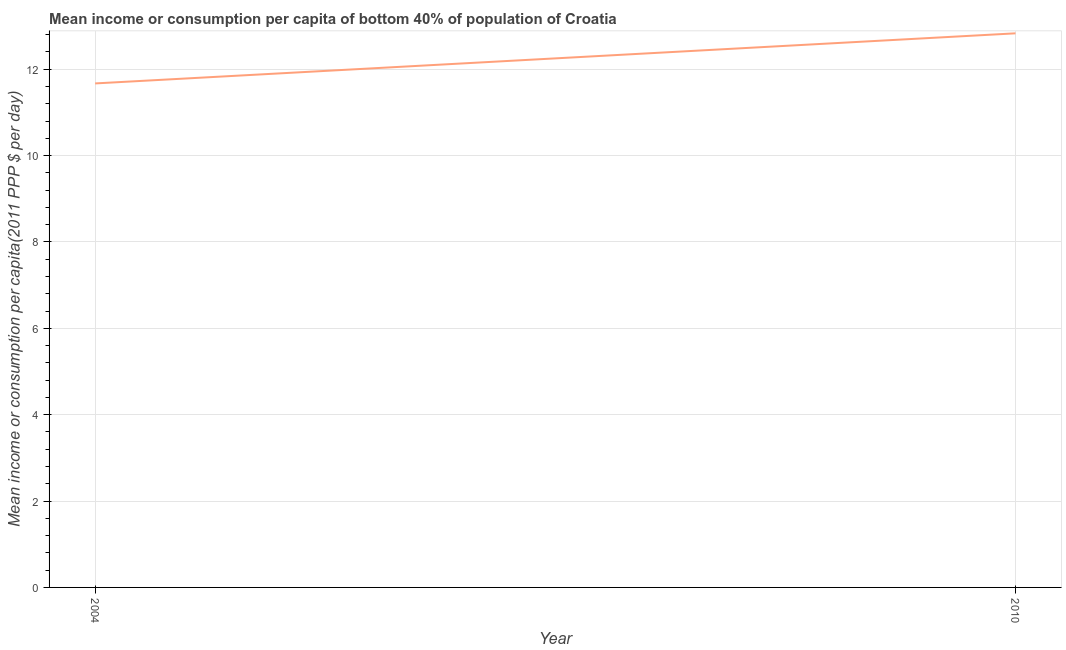What is the mean income or consumption in 2004?
Your response must be concise. 11.67. Across all years, what is the maximum mean income or consumption?
Give a very brief answer. 12.83. Across all years, what is the minimum mean income or consumption?
Your answer should be very brief. 11.67. In which year was the mean income or consumption minimum?
Ensure brevity in your answer.  2004. What is the sum of the mean income or consumption?
Give a very brief answer. 24.5. What is the difference between the mean income or consumption in 2004 and 2010?
Provide a succinct answer. -1.16. What is the average mean income or consumption per year?
Offer a terse response. 12.25. What is the median mean income or consumption?
Offer a very short reply. 12.25. Do a majority of the years between 2010 and 2004 (inclusive) have mean income or consumption greater than 2 $?
Your answer should be very brief. No. What is the ratio of the mean income or consumption in 2004 to that in 2010?
Make the answer very short. 0.91. Is the mean income or consumption in 2004 less than that in 2010?
Ensure brevity in your answer.  Yes. In how many years, is the mean income or consumption greater than the average mean income or consumption taken over all years?
Keep it short and to the point. 1. How many lines are there?
Offer a very short reply. 1. Does the graph contain any zero values?
Make the answer very short. No. Does the graph contain grids?
Your response must be concise. Yes. What is the title of the graph?
Give a very brief answer. Mean income or consumption per capita of bottom 40% of population of Croatia. What is the label or title of the X-axis?
Your answer should be very brief. Year. What is the label or title of the Y-axis?
Offer a terse response. Mean income or consumption per capita(2011 PPP $ per day). What is the Mean income or consumption per capita(2011 PPP $ per day) of 2004?
Provide a succinct answer. 11.67. What is the Mean income or consumption per capita(2011 PPP $ per day) of 2010?
Ensure brevity in your answer.  12.83. What is the difference between the Mean income or consumption per capita(2011 PPP $ per day) in 2004 and 2010?
Provide a short and direct response. -1.16. What is the ratio of the Mean income or consumption per capita(2011 PPP $ per day) in 2004 to that in 2010?
Your response must be concise. 0.91. 